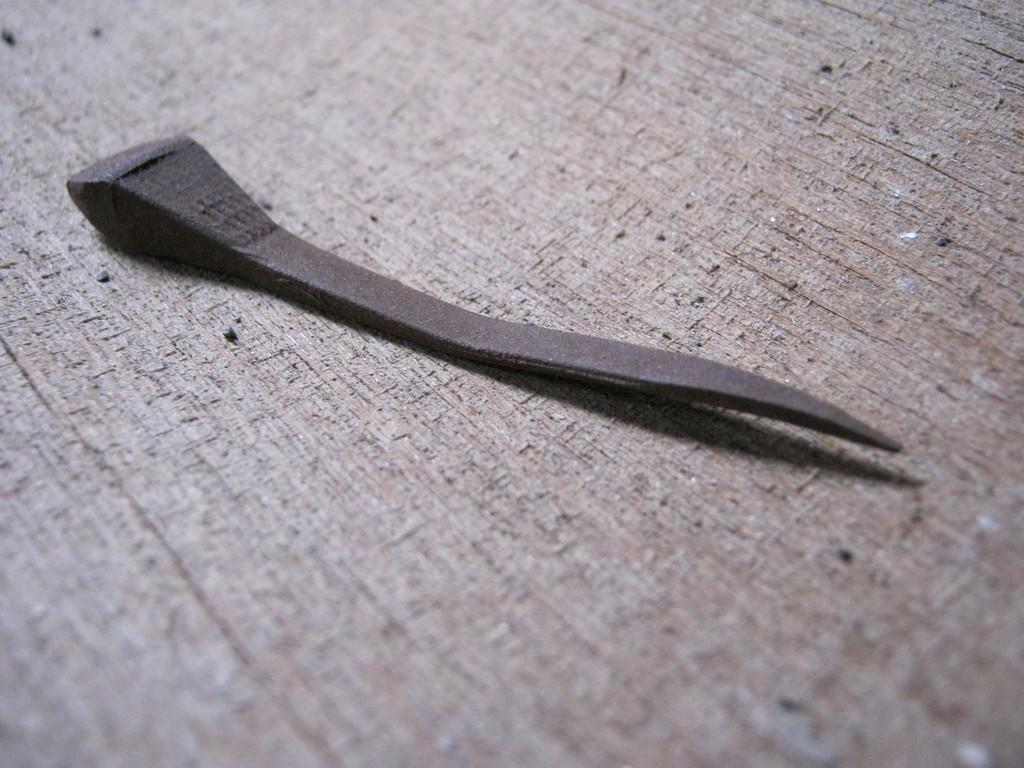What is the main subject in the center of the image? There is an object in the center of the image. Can you describe the setting or environment in the image? There is a table in the background of the image. How many cherries are on the edge of the table in the image? There is no mention of cherries or an edge in the provided facts, so we cannot answer this question based on the image. 